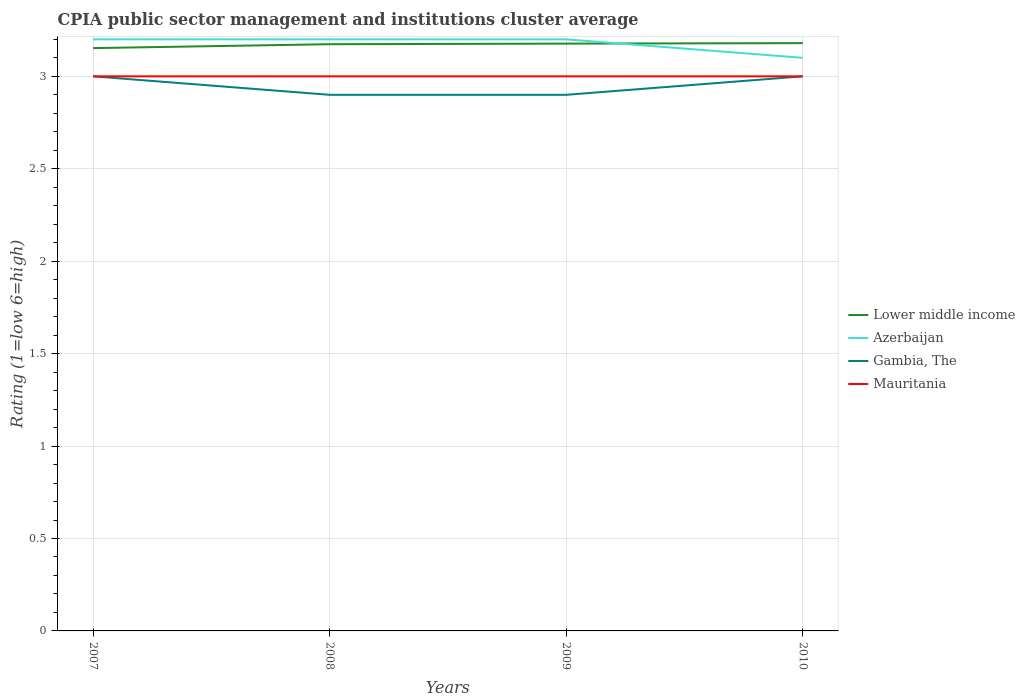How many different coloured lines are there?
Your answer should be compact. 4. Does the line corresponding to Lower middle income intersect with the line corresponding to Mauritania?
Give a very brief answer. No. What is the total CPIA rating in Lower middle income in the graph?
Your response must be concise. -0.03. What is the difference between the highest and the second highest CPIA rating in Gambia, The?
Offer a terse response. 0.1. What is the difference between the highest and the lowest CPIA rating in Mauritania?
Make the answer very short. 0. How many lines are there?
Provide a short and direct response. 4. How many years are there in the graph?
Your answer should be very brief. 4. Are the values on the major ticks of Y-axis written in scientific E-notation?
Provide a succinct answer. No. Does the graph contain any zero values?
Make the answer very short. No. Does the graph contain grids?
Your answer should be compact. Yes. Where does the legend appear in the graph?
Your response must be concise. Center right. How many legend labels are there?
Provide a succinct answer. 4. How are the legend labels stacked?
Your answer should be very brief. Vertical. What is the title of the graph?
Give a very brief answer. CPIA public sector management and institutions cluster average. Does "Euro area" appear as one of the legend labels in the graph?
Your answer should be compact. No. What is the Rating (1=low 6=high) of Lower middle income in 2007?
Provide a short and direct response. 3.15. What is the Rating (1=low 6=high) in Lower middle income in 2008?
Make the answer very short. 3.17. What is the Rating (1=low 6=high) in Azerbaijan in 2008?
Your answer should be compact. 3.2. What is the Rating (1=low 6=high) in Gambia, The in 2008?
Offer a terse response. 2.9. What is the Rating (1=low 6=high) of Lower middle income in 2009?
Your response must be concise. 3.18. What is the Rating (1=low 6=high) in Lower middle income in 2010?
Provide a short and direct response. 3.18. What is the Rating (1=low 6=high) in Azerbaijan in 2010?
Provide a short and direct response. 3.1. What is the Rating (1=low 6=high) of Gambia, The in 2010?
Offer a terse response. 3. Across all years, what is the maximum Rating (1=low 6=high) of Lower middle income?
Keep it short and to the point. 3.18. Across all years, what is the maximum Rating (1=low 6=high) in Azerbaijan?
Offer a very short reply. 3.2. Across all years, what is the maximum Rating (1=low 6=high) of Gambia, The?
Provide a succinct answer. 3. Across all years, what is the minimum Rating (1=low 6=high) of Lower middle income?
Make the answer very short. 3.15. Across all years, what is the minimum Rating (1=low 6=high) of Azerbaijan?
Ensure brevity in your answer.  3.1. Across all years, what is the minimum Rating (1=low 6=high) in Mauritania?
Offer a very short reply. 3. What is the total Rating (1=low 6=high) in Lower middle income in the graph?
Provide a succinct answer. 12.68. What is the total Rating (1=low 6=high) of Gambia, The in the graph?
Offer a terse response. 11.8. What is the total Rating (1=low 6=high) of Mauritania in the graph?
Provide a succinct answer. 12. What is the difference between the Rating (1=low 6=high) of Lower middle income in 2007 and that in 2008?
Provide a short and direct response. -0.02. What is the difference between the Rating (1=low 6=high) of Azerbaijan in 2007 and that in 2008?
Give a very brief answer. 0. What is the difference between the Rating (1=low 6=high) of Mauritania in 2007 and that in 2008?
Keep it short and to the point. 0. What is the difference between the Rating (1=low 6=high) of Lower middle income in 2007 and that in 2009?
Ensure brevity in your answer.  -0.02. What is the difference between the Rating (1=low 6=high) of Gambia, The in 2007 and that in 2009?
Offer a terse response. 0.1. What is the difference between the Rating (1=low 6=high) in Mauritania in 2007 and that in 2009?
Your response must be concise. 0. What is the difference between the Rating (1=low 6=high) in Lower middle income in 2007 and that in 2010?
Ensure brevity in your answer.  -0.03. What is the difference between the Rating (1=low 6=high) of Gambia, The in 2007 and that in 2010?
Provide a short and direct response. 0. What is the difference between the Rating (1=low 6=high) of Mauritania in 2007 and that in 2010?
Your response must be concise. 0. What is the difference between the Rating (1=low 6=high) of Lower middle income in 2008 and that in 2009?
Your answer should be very brief. -0. What is the difference between the Rating (1=low 6=high) of Mauritania in 2008 and that in 2009?
Provide a short and direct response. 0. What is the difference between the Rating (1=low 6=high) in Lower middle income in 2008 and that in 2010?
Provide a short and direct response. -0.01. What is the difference between the Rating (1=low 6=high) of Azerbaijan in 2008 and that in 2010?
Your response must be concise. 0.1. What is the difference between the Rating (1=low 6=high) in Mauritania in 2008 and that in 2010?
Your answer should be very brief. 0. What is the difference between the Rating (1=low 6=high) of Lower middle income in 2009 and that in 2010?
Give a very brief answer. -0. What is the difference between the Rating (1=low 6=high) in Azerbaijan in 2009 and that in 2010?
Your response must be concise. 0.1. What is the difference between the Rating (1=low 6=high) in Lower middle income in 2007 and the Rating (1=low 6=high) in Azerbaijan in 2008?
Make the answer very short. -0.05. What is the difference between the Rating (1=low 6=high) of Lower middle income in 2007 and the Rating (1=low 6=high) of Gambia, The in 2008?
Ensure brevity in your answer.  0.25. What is the difference between the Rating (1=low 6=high) of Lower middle income in 2007 and the Rating (1=low 6=high) of Mauritania in 2008?
Provide a succinct answer. 0.15. What is the difference between the Rating (1=low 6=high) of Gambia, The in 2007 and the Rating (1=low 6=high) of Mauritania in 2008?
Make the answer very short. 0. What is the difference between the Rating (1=low 6=high) of Lower middle income in 2007 and the Rating (1=low 6=high) of Azerbaijan in 2009?
Ensure brevity in your answer.  -0.05. What is the difference between the Rating (1=low 6=high) in Lower middle income in 2007 and the Rating (1=low 6=high) in Gambia, The in 2009?
Make the answer very short. 0.25. What is the difference between the Rating (1=low 6=high) in Lower middle income in 2007 and the Rating (1=low 6=high) in Mauritania in 2009?
Your response must be concise. 0.15. What is the difference between the Rating (1=low 6=high) of Azerbaijan in 2007 and the Rating (1=low 6=high) of Gambia, The in 2009?
Keep it short and to the point. 0.3. What is the difference between the Rating (1=low 6=high) in Azerbaijan in 2007 and the Rating (1=low 6=high) in Mauritania in 2009?
Provide a short and direct response. 0.2. What is the difference between the Rating (1=low 6=high) in Gambia, The in 2007 and the Rating (1=low 6=high) in Mauritania in 2009?
Provide a short and direct response. 0. What is the difference between the Rating (1=low 6=high) in Lower middle income in 2007 and the Rating (1=low 6=high) in Azerbaijan in 2010?
Your answer should be very brief. 0.05. What is the difference between the Rating (1=low 6=high) of Lower middle income in 2007 and the Rating (1=low 6=high) of Gambia, The in 2010?
Make the answer very short. 0.15. What is the difference between the Rating (1=low 6=high) in Lower middle income in 2007 and the Rating (1=low 6=high) in Mauritania in 2010?
Offer a terse response. 0.15. What is the difference between the Rating (1=low 6=high) in Azerbaijan in 2007 and the Rating (1=low 6=high) in Gambia, The in 2010?
Make the answer very short. 0.2. What is the difference between the Rating (1=low 6=high) of Azerbaijan in 2007 and the Rating (1=low 6=high) of Mauritania in 2010?
Your answer should be very brief. 0.2. What is the difference between the Rating (1=low 6=high) in Lower middle income in 2008 and the Rating (1=low 6=high) in Azerbaijan in 2009?
Ensure brevity in your answer.  -0.03. What is the difference between the Rating (1=low 6=high) of Lower middle income in 2008 and the Rating (1=low 6=high) of Gambia, The in 2009?
Offer a very short reply. 0.27. What is the difference between the Rating (1=low 6=high) in Lower middle income in 2008 and the Rating (1=low 6=high) in Mauritania in 2009?
Ensure brevity in your answer.  0.17. What is the difference between the Rating (1=low 6=high) in Azerbaijan in 2008 and the Rating (1=low 6=high) in Mauritania in 2009?
Give a very brief answer. 0.2. What is the difference between the Rating (1=low 6=high) in Lower middle income in 2008 and the Rating (1=low 6=high) in Azerbaijan in 2010?
Provide a succinct answer. 0.07. What is the difference between the Rating (1=low 6=high) in Lower middle income in 2008 and the Rating (1=low 6=high) in Gambia, The in 2010?
Make the answer very short. 0.17. What is the difference between the Rating (1=low 6=high) in Lower middle income in 2008 and the Rating (1=low 6=high) in Mauritania in 2010?
Keep it short and to the point. 0.17. What is the difference between the Rating (1=low 6=high) in Azerbaijan in 2008 and the Rating (1=low 6=high) in Mauritania in 2010?
Your response must be concise. 0.2. What is the difference between the Rating (1=low 6=high) in Gambia, The in 2008 and the Rating (1=low 6=high) in Mauritania in 2010?
Provide a succinct answer. -0.1. What is the difference between the Rating (1=low 6=high) of Lower middle income in 2009 and the Rating (1=low 6=high) of Azerbaijan in 2010?
Provide a succinct answer. 0.08. What is the difference between the Rating (1=low 6=high) of Lower middle income in 2009 and the Rating (1=low 6=high) of Gambia, The in 2010?
Your answer should be compact. 0.18. What is the difference between the Rating (1=low 6=high) of Lower middle income in 2009 and the Rating (1=low 6=high) of Mauritania in 2010?
Make the answer very short. 0.18. What is the difference between the Rating (1=low 6=high) of Azerbaijan in 2009 and the Rating (1=low 6=high) of Gambia, The in 2010?
Offer a very short reply. 0.2. What is the difference between the Rating (1=low 6=high) of Gambia, The in 2009 and the Rating (1=low 6=high) of Mauritania in 2010?
Ensure brevity in your answer.  -0.1. What is the average Rating (1=low 6=high) in Lower middle income per year?
Offer a terse response. 3.17. What is the average Rating (1=low 6=high) of Azerbaijan per year?
Offer a terse response. 3.17. What is the average Rating (1=low 6=high) in Gambia, The per year?
Give a very brief answer. 2.95. What is the average Rating (1=low 6=high) in Mauritania per year?
Your answer should be very brief. 3. In the year 2007, what is the difference between the Rating (1=low 6=high) of Lower middle income and Rating (1=low 6=high) of Azerbaijan?
Provide a succinct answer. -0.05. In the year 2007, what is the difference between the Rating (1=low 6=high) in Lower middle income and Rating (1=low 6=high) in Gambia, The?
Provide a succinct answer. 0.15. In the year 2007, what is the difference between the Rating (1=low 6=high) in Lower middle income and Rating (1=low 6=high) in Mauritania?
Your response must be concise. 0.15. In the year 2008, what is the difference between the Rating (1=low 6=high) in Lower middle income and Rating (1=low 6=high) in Azerbaijan?
Your answer should be compact. -0.03. In the year 2008, what is the difference between the Rating (1=low 6=high) in Lower middle income and Rating (1=low 6=high) in Gambia, The?
Keep it short and to the point. 0.27. In the year 2008, what is the difference between the Rating (1=low 6=high) in Lower middle income and Rating (1=low 6=high) in Mauritania?
Keep it short and to the point. 0.17. In the year 2009, what is the difference between the Rating (1=low 6=high) in Lower middle income and Rating (1=low 6=high) in Azerbaijan?
Your response must be concise. -0.02. In the year 2009, what is the difference between the Rating (1=low 6=high) in Lower middle income and Rating (1=low 6=high) in Gambia, The?
Your answer should be compact. 0.28. In the year 2009, what is the difference between the Rating (1=low 6=high) of Lower middle income and Rating (1=low 6=high) of Mauritania?
Your answer should be compact. 0.18. In the year 2009, what is the difference between the Rating (1=low 6=high) of Azerbaijan and Rating (1=low 6=high) of Gambia, The?
Offer a terse response. 0.3. In the year 2009, what is the difference between the Rating (1=low 6=high) in Azerbaijan and Rating (1=low 6=high) in Mauritania?
Your answer should be very brief. 0.2. In the year 2010, what is the difference between the Rating (1=low 6=high) in Lower middle income and Rating (1=low 6=high) in Azerbaijan?
Your answer should be compact. 0.08. In the year 2010, what is the difference between the Rating (1=low 6=high) in Lower middle income and Rating (1=low 6=high) in Gambia, The?
Provide a succinct answer. 0.18. In the year 2010, what is the difference between the Rating (1=low 6=high) of Lower middle income and Rating (1=low 6=high) of Mauritania?
Make the answer very short. 0.18. What is the ratio of the Rating (1=low 6=high) of Azerbaijan in 2007 to that in 2008?
Offer a very short reply. 1. What is the ratio of the Rating (1=low 6=high) of Gambia, The in 2007 to that in 2008?
Your answer should be compact. 1.03. What is the ratio of the Rating (1=low 6=high) of Mauritania in 2007 to that in 2008?
Give a very brief answer. 1. What is the ratio of the Rating (1=low 6=high) in Gambia, The in 2007 to that in 2009?
Your answer should be compact. 1.03. What is the ratio of the Rating (1=low 6=high) of Mauritania in 2007 to that in 2009?
Give a very brief answer. 1. What is the ratio of the Rating (1=low 6=high) of Azerbaijan in 2007 to that in 2010?
Your answer should be very brief. 1.03. What is the ratio of the Rating (1=low 6=high) in Lower middle income in 2008 to that in 2009?
Offer a terse response. 1. What is the ratio of the Rating (1=low 6=high) of Gambia, The in 2008 to that in 2009?
Provide a short and direct response. 1. What is the ratio of the Rating (1=low 6=high) of Mauritania in 2008 to that in 2009?
Your answer should be compact. 1. What is the ratio of the Rating (1=low 6=high) in Azerbaijan in 2008 to that in 2010?
Provide a short and direct response. 1.03. What is the ratio of the Rating (1=low 6=high) of Gambia, The in 2008 to that in 2010?
Provide a short and direct response. 0.97. What is the ratio of the Rating (1=low 6=high) in Mauritania in 2008 to that in 2010?
Make the answer very short. 1. What is the ratio of the Rating (1=low 6=high) of Azerbaijan in 2009 to that in 2010?
Your response must be concise. 1.03. What is the ratio of the Rating (1=low 6=high) in Gambia, The in 2009 to that in 2010?
Your answer should be very brief. 0.97. What is the ratio of the Rating (1=low 6=high) of Mauritania in 2009 to that in 2010?
Make the answer very short. 1. What is the difference between the highest and the second highest Rating (1=low 6=high) of Lower middle income?
Your response must be concise. 0. What is the difference between the highest and the lowest Rating (1=low 6=high) of Lower middle income?
Offer a terse response. 0.03. What is the difference between the highest and the lowest Rating (1=low 6=high) in Azerbaijan?
Offer a very short reply. 0.1. 